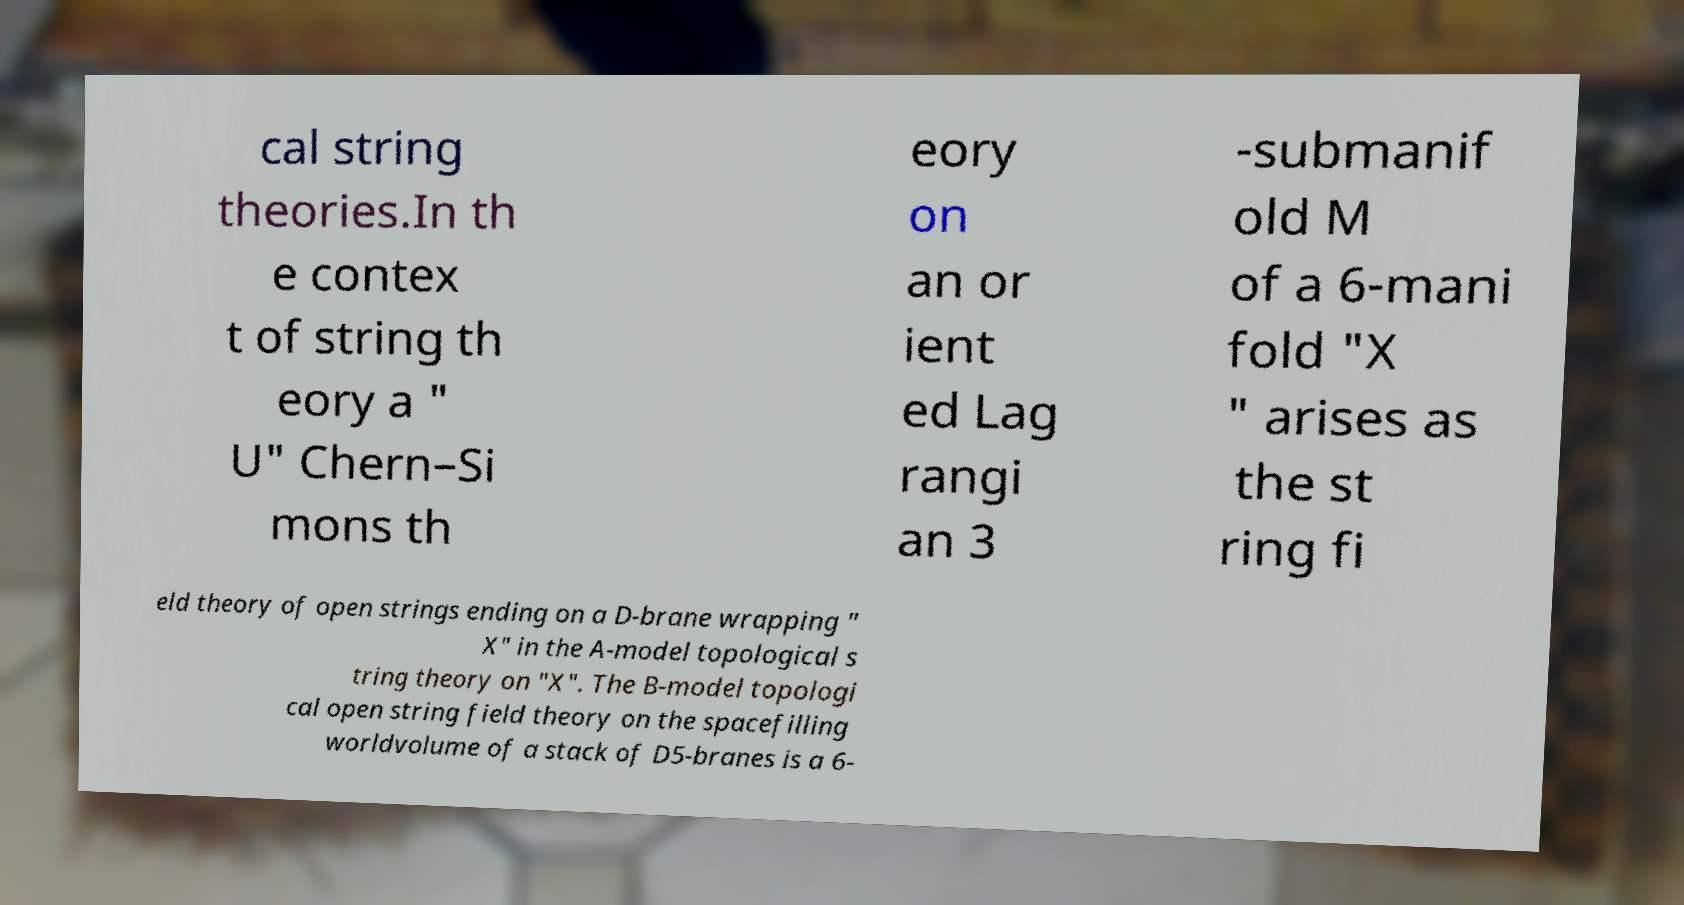For documentation purposes, I need the text within this image transcribed. Could you provide that? cal string theories.In th e contex t of string th eory a " U" Chern–Si mons th eory on an or ient ed Lag rangi an 3 -submanif old M of a 6-mani fold "X " arises as the st ring fi eld theory of open strings ending on a D-brane wrapping " X" in the A-model topological s tring theory on "X". The B-model topologi cal open string field theory on the spacefilling worldvolume of a stack of D5-branes is a 6- 